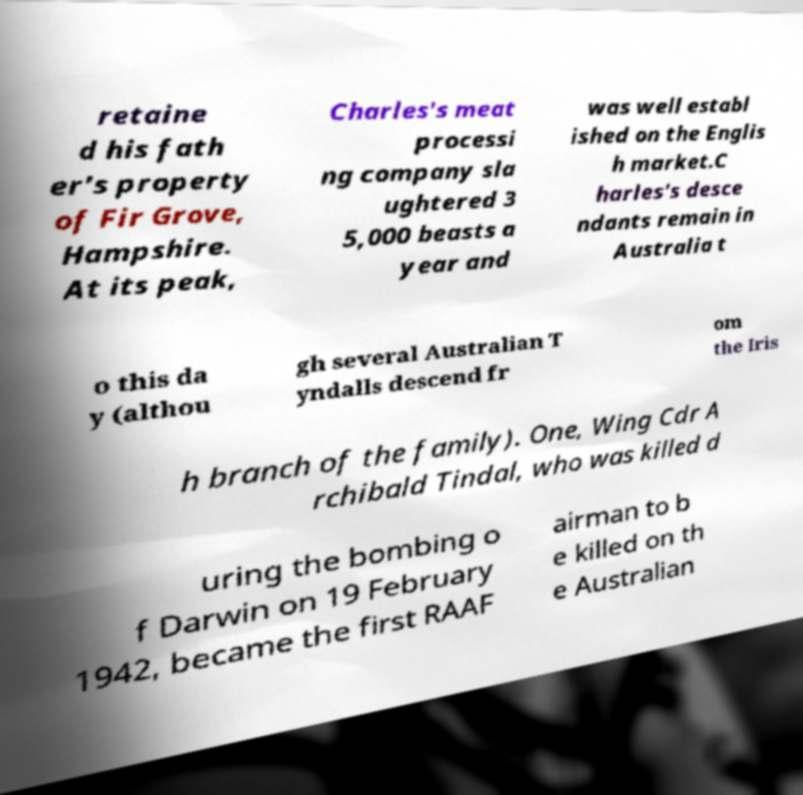I need the written content from this picture converted into text. Can you do that? retaine d his fath er's property of Fir Grove, Hampshire. At its peak, Charles's meat processi ng company sla ughtered 3 5,000 beasts a year and was well establ ished on the Englis h market.C harles's desce ndants remain in Australia t o this da y (althou gh several Australian T yndalls descend fr om the Iris h branch of the family). One, Wing Cdr A rchibald Tindal, who was killed d uring the bombing o f Darwin on 19 February 1942, became the first RAAF airman to b e killed on th e Australian 